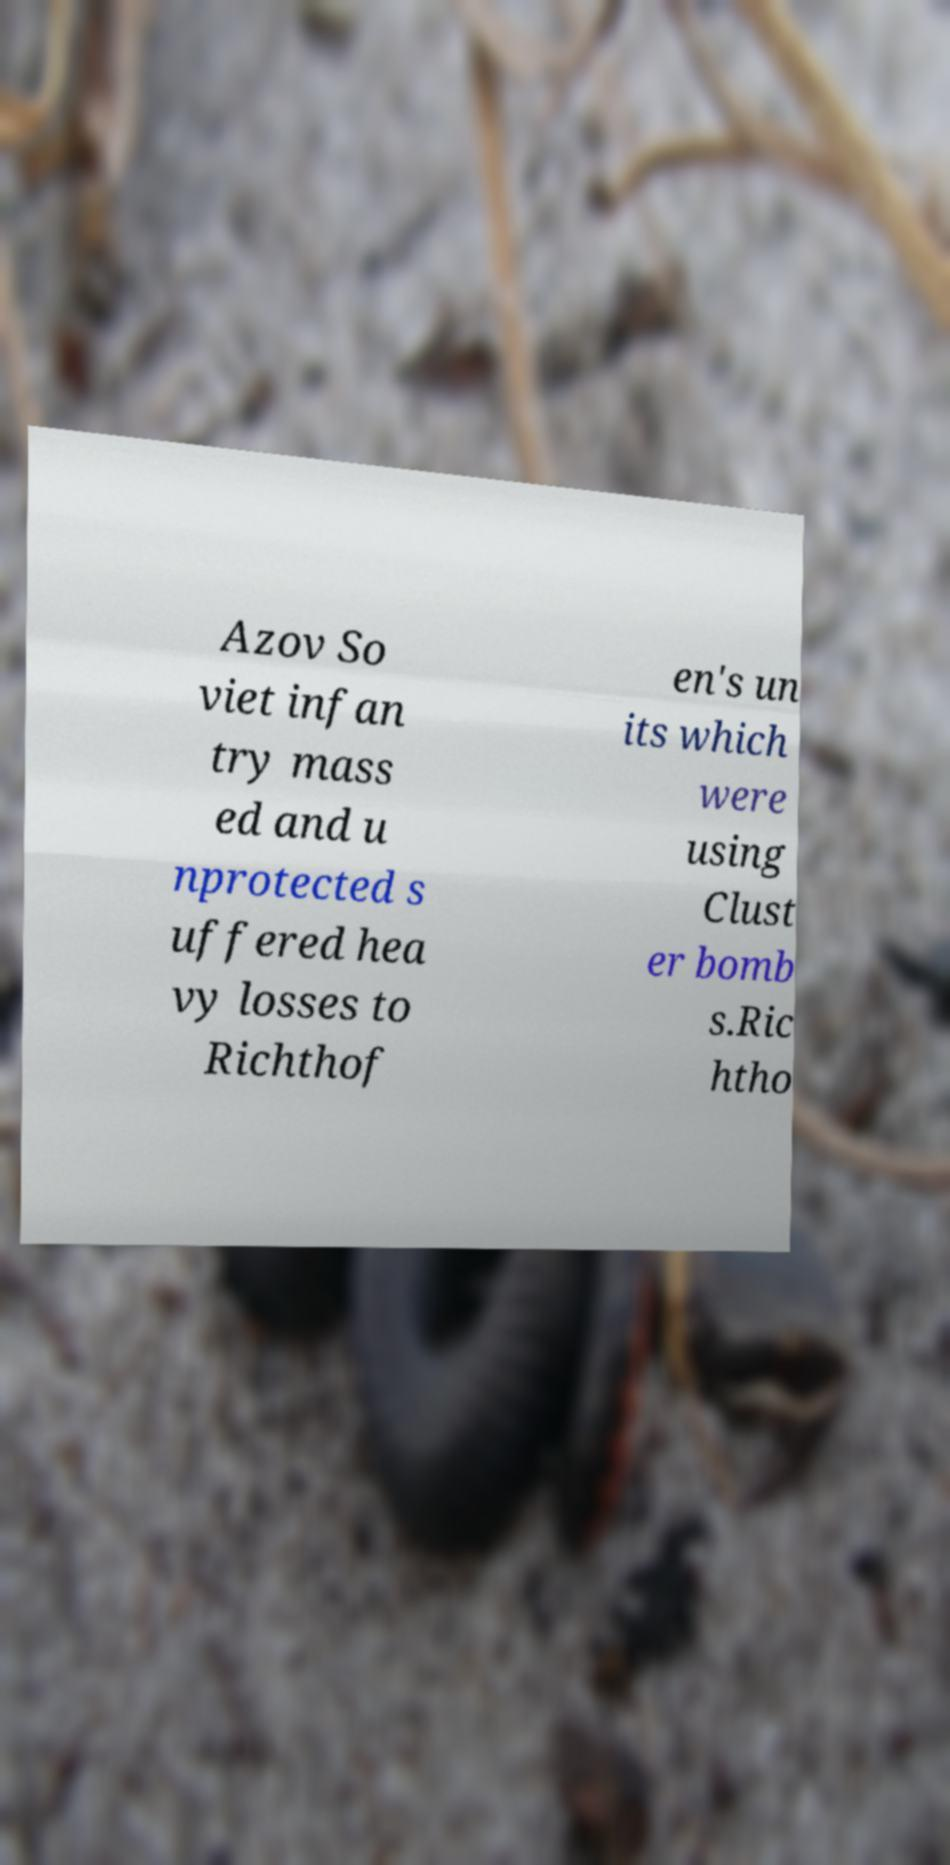Please read and relay the text visible in this image. What does it say? Azov So viet infan try mass ed and u nprotected s uffered hea vy losses to Richthof en's un its which were using Clust er bomb s.Ric htho 